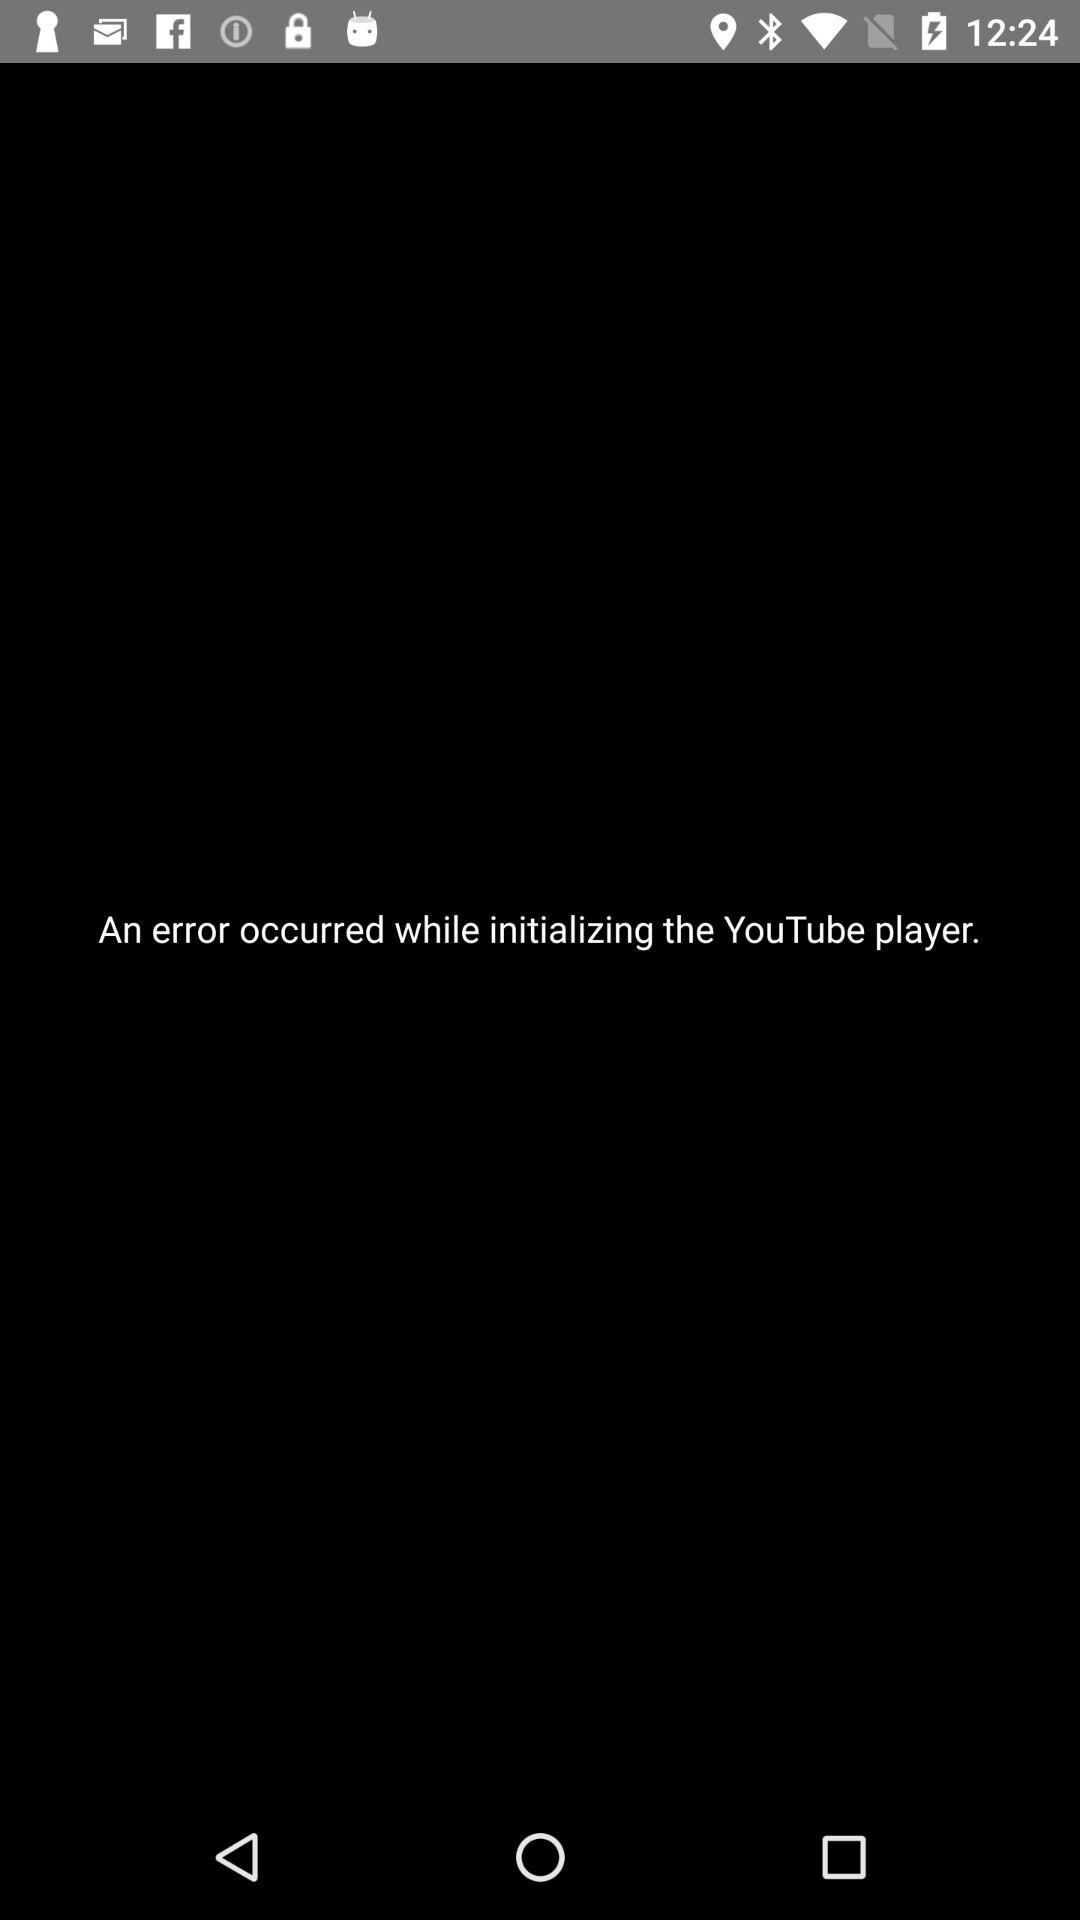While installing which app, an error occurred? An error occurred while installing the YouTube player. 